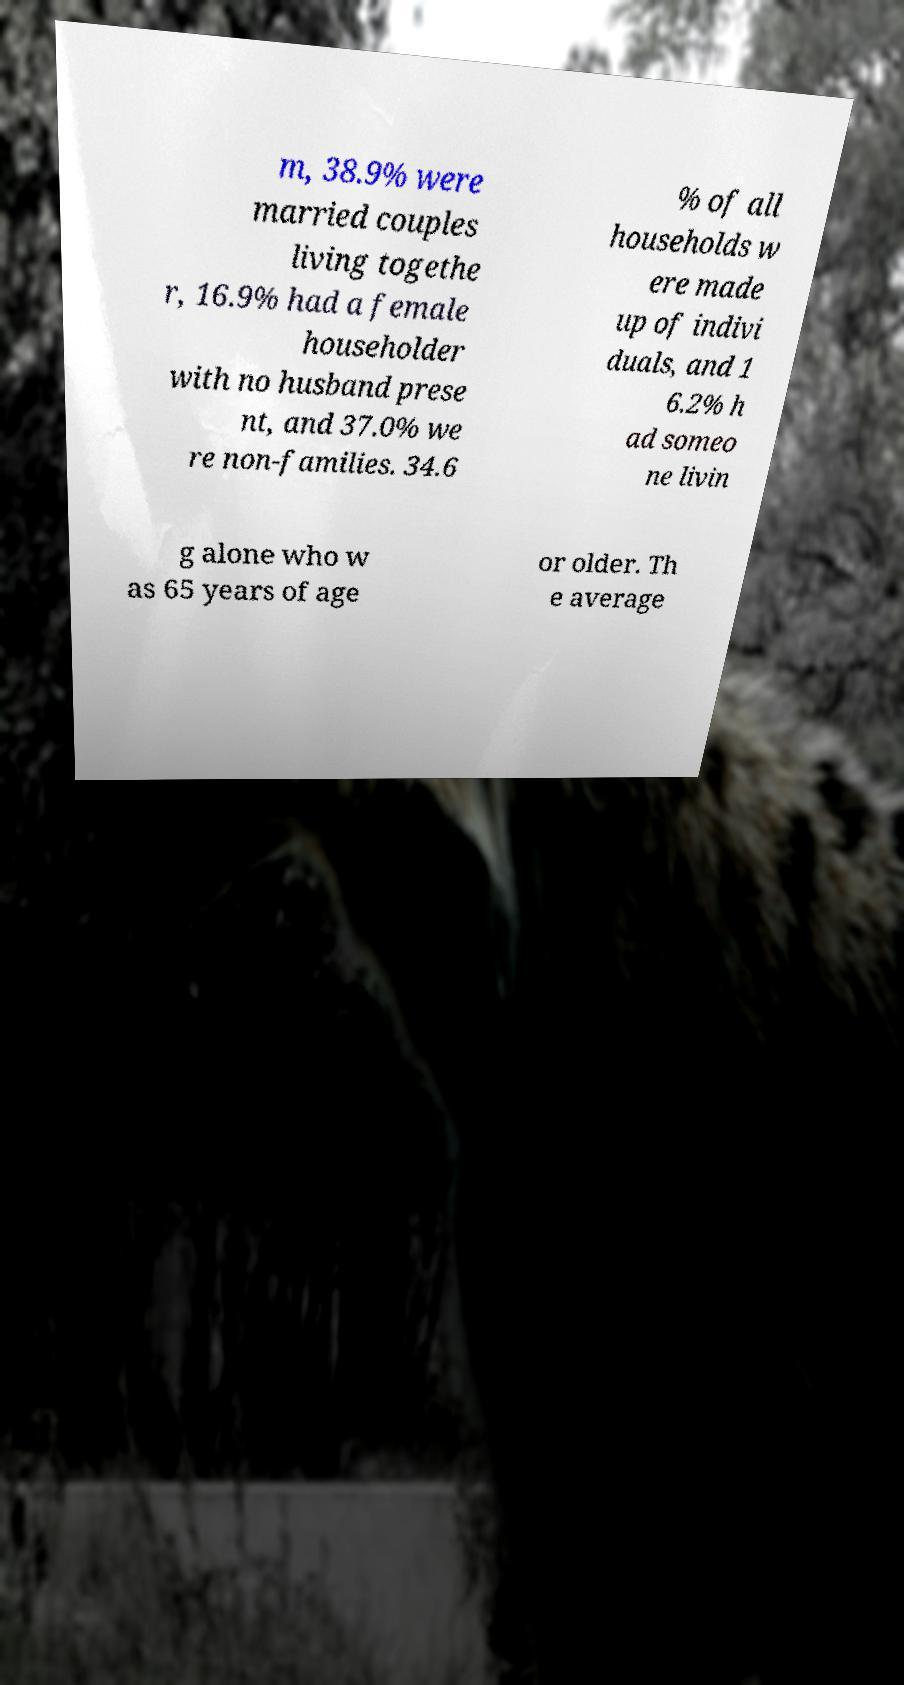Can you accurately transcribe the text from the provided image for me? m, 38.9% were married couples living togethe r, 16.9% had a female householder with no husband prese nt, and 37.0% we re non-families. 34.6 % of all households w ere made up of indivi duals, and 1 6.2% h ad someo ne livin g alone who w as 65 years of age or older. Th e average 